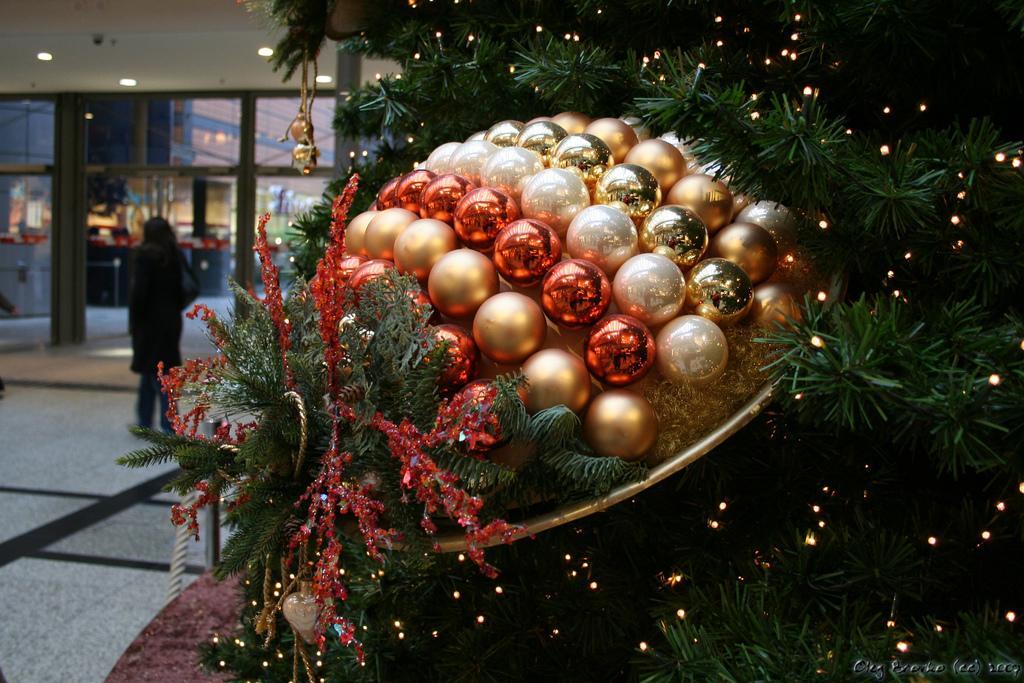In one or two sentences, can you explain what this image depicts? On the right we can see a tree with lights decorated on it and there are different colors of spherical balls on a platform on the tree. In the background on the left a woman is standing on the floor,glass doors,lights on the roof top,buildings and other objects. 